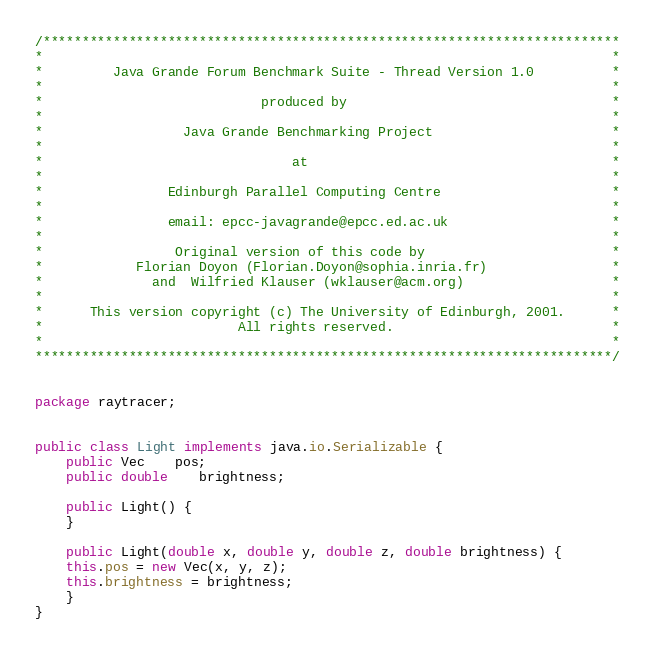<code> <loc_0><loc_0><loc_500><loc_500><_Java_>/**************************************************************************
*                                                                         *
*         Java Grande Forum Benchmark Suite - Thread Version 1.0          *
*                                                                         *
*                            produced by                                  *
*                                                                         *
*                  Java Grande Benchmarking Project                       *
*                                                                         *
*                                at                                       *
*                                                                         *
*                Edinburgh Parallel Computing Centre                      *
*                                                                         *
*                email: epcc-javagrande@epcc.ed.ac.uk                     *
*                                                                         *
*                 Original version of this code by                        *
*            Florian Doyon (Florian.Doyon@sophia.inria.fr)                *
*              and  Wilfried Klauser (wklauser@acm.org)                   *
*                                                                         *
*      This version copyright (c) The University of Edinburgh, 2001.      *
*                         All rights reserved.                            *
*                                                                         *
**************************************************************************/


package raytracer; 


public class Light implements java.io.Serializable {
    public Vec	pos;
    public double	brightness;
	
    public Light() {
    }
    
    public Light(double x, double y, double z, double brightness) {
	this.pos = new Vec(x, y, z);
	this.brightness = brightness;
    }
}
</code> 